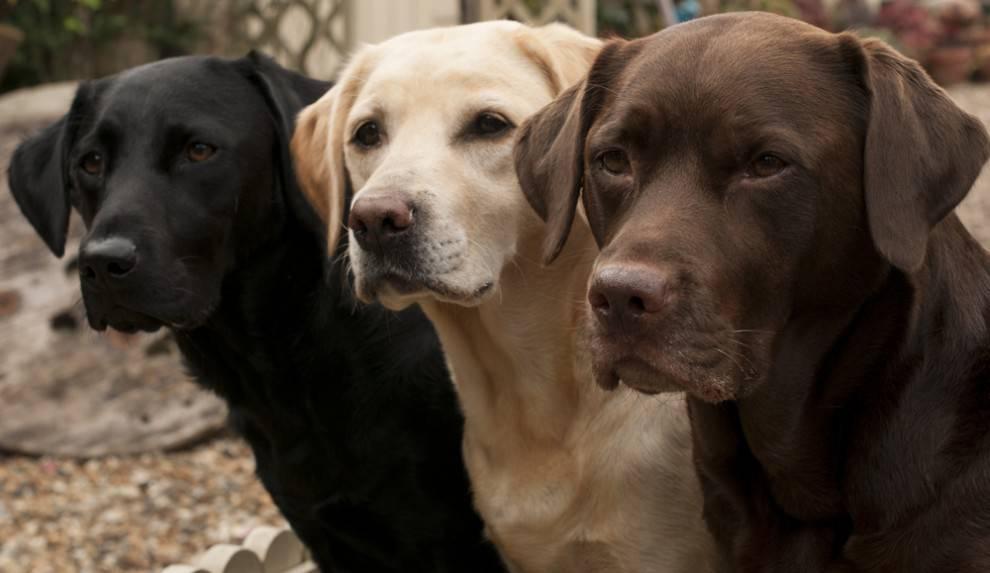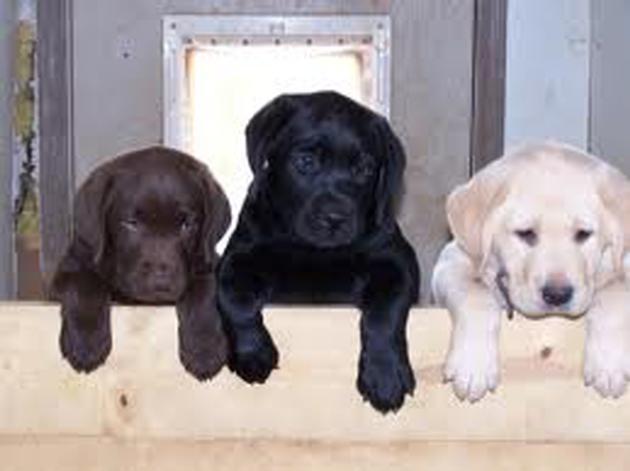The first image is the image on the left, the second image is the image on the right. Analyze the images presented: Is the assertion "There are the same number of dogs in each image, but they are a different age in one image than the other." valid? Answer yes or no. Yes. The first image is the image on the left, the second image is the image on the right. For the images displayed, is the sentence "One picture shows a brown dog, a light cream dog, and a black dog next to each other, with the light dog in the middle." factually correct? Answer yes or no. Yes. 